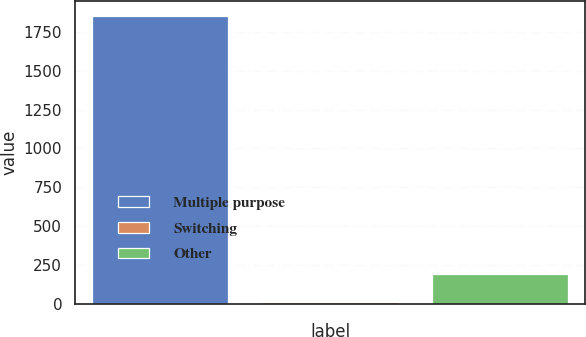Convert chart to OTSL. <chart><loc_0><loc_0><loc_500><loc_500><bar_chart><fcel>Multiple purpose<fcel>Switching<fcel>Other<nl><fcel>1852<fcel>12<fcel>196<nl></chart> 